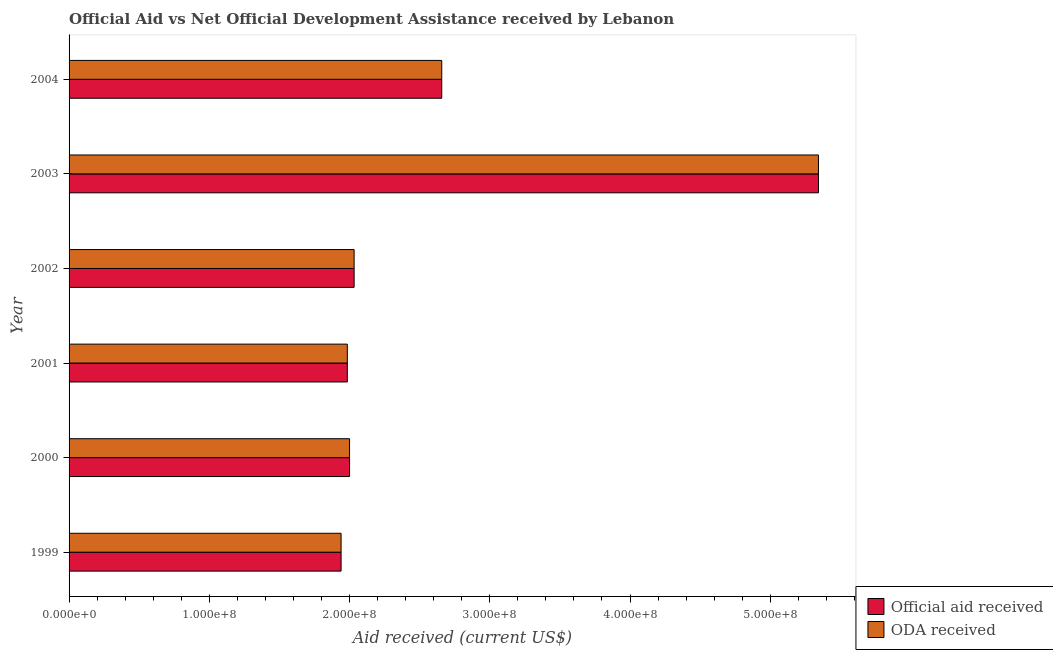How many different coloured bars are there?
Provide a short and direct response. 2. How many groups of bars are there?
Your answer should be compact. 6. Are the number of bars per tick equal to the number of legend labels?
Your response must be concise. Yes. Are the number of bars on each tick of the Y-axis equal?
Provide a short and direct response. Yes. How many bars are there on the 6th tick from the top?
Your response must be concise. 2. What is the label of the 1st group of bars from the top?
Your answer should be very brief. 2004. In how many cases, is the number of bars for a given year not equal to the number of legend labels?
Your answer should be very brief. 0. What is the official aid received in 2003?
Provide a succinct answer. 5.34e+08. Across all years, what is the maximum official aid received?
Provide a short and direct response. 5.34e+08. Across all years, what is the minimum oda received?
Make the answer very short. 1.94e+08. What is the total oda received in the graph?
Your answer should be very brief. 1.60e+09. What is the difference between the oda received in 2000 and that in 2002?
Give a very brief answer. -3.26e+06. What is the difference between the oda received in 2004 and the official aid received in 2003?
Offer a terse response. -2.69e+08. What is the average official aid received per year?
Keep it short and to the point. 2.66e+08. In the year 2004, what is the difference between the oda received and official aid received?
Provide a short and direct response. 0. In how many years, is the official aid received greater than 360000000 US$?
Offer a very short reply. 1. What is the ratio of the oda received in 2003 to that in 2004?
Provide a short and direct response. 2.01. What is the difference between the highest and the second highest oda received?
Keep it short and to the point. 2.69e+08. What is the difference between the highest and the lowest official aid received?
Offer a very short reply. 3.40e+08. What does the 2nd bar from the top in 2004 represents?
Your answer should be compact. Official aid received. What does the 2nd bar from the bottom in 1999 represents?
Your answer should be compact. ODA received. How many bars are there?
Provide a succinct answer. 12. What is the difference between two consecutive major ticks on the X-axis?
Offer a terse response. 1.00e+08. Are the values on the major ticks of X-axis written in scientific E-notation?
Your answer should be very brief. Yes. How many legend labels are there?
Provide a short and direct response. 2. What is the title of the graph?
Ensure brevity in your answer.  Official Aid vs Net Official Development Assistance received by Lebanon . Does "Taxes on exports" appear as one of the legend labels in the graph?
Your response must be concise. No. What is the label or title of the X-axis?
Provide a succinct answer. Aid received (current US$). What is the label or title of the Y-axis?
Give a very brief answer. Year. What is the Aid received (current US$) in Official aid received in 1999?
Give a very brief answer. 1.94e+08. What is the Aid received (current US$) of ODA received in 1999?
Make the answer very short. 1.94e+08. What is the Aid received (current US$) of Official aid received in 2000?
Offer a terse response. 2.00e+08. What is the Aid received (current US$) in ODA received in 2000?
Provide a short and direct response. 2.00e+08. What is the Aid received (current US$) in Official aid received in 2001?
Provide a short and direct response. 1.98e+08. What is the Aid received (current US$) of ODA received in 2001?
Ensure brevity in your answer.  1.98e+08. What is the Aid received (current US$) in Official aid received in 2002?
Ensure brevity in your answer.  2.03e+08. What is the Aid received (current US$) in ODA received in 2002?
Give a very brief answer. 2.03e+08. What is the Aid received (current US$) of Official aid received in 2003?
Ensure brevity in your answer.  5.34e+08. What is the Aid received (current US$) in ODA received in 2003?
Your answer should be compact. 5.34e+08. What is the Aid received (current US$) of Official aid received in 2004?
Give a very brief answer. 2.66e+08. What is the Aid received (current US$) of ODA received in 2004?
Offer a very short reply. 2.66e+08. Across all years, what is the maximum Aid received (current US$) in Official aid received?
Your answer should be very brief. 5.34e+08. Across all years, what is the maximum Aid received (current US$) in ODA received?
Your answer should be compact. 5.34e+08. Across all years, what is the minimum Aid received (current US$) in Official aid received?
Ensure brevity in your answer.  1.94e+08. Across all years, what is the minimum Aid received (current US$) in ODA received?
Provide a short and direct response. 1.94e+08. What is the total Aid received (current US$) in Official aid received in the graph?
Give a very brief answer. 1.60e+09. What is the total Aid received (current US$) in ODA received in the graph?
Offer a very short reply. 1.60e+09. What is the difference between the Aid received (current US$) in Official aid received in 1999 and that in 2000?
Ensure brevity in your answer.  -6.05e+06. What is the difference between the Aid received (current US$) in ODA received in 1999 and that in 2000?
Offer a very short reply. -6.05e+06. What is the difference between the Aid received (current US$) in Official aid received in 1999 and that in 2001?
Offer a very short reply. -4.46e+06. What is the difference between the Aid received (current US$) in ODA received in 1999 and that in 2001?
Your response must be concise. -4.46e+06. What is the difference between the Aid received (current US$) in Official aid received in 1999 and that in 2002?
Ensure brevity in your answer.  -9.31e+06. What is the difference between the Aid received (current US$) in ODA received in 1999 and that in 2002?
Keep it short and to the point. -9.31e+06. What is the difference between the Aid received (current US$) of Official aid received in 1999 and that in 2003?
Provide a succinct answer. -3.40e+08. What is the difference between the Aid received (current US$) in ODA received in 1999 and that in 2003?
Make the answer very short. -3.40e+08. What is the difference between the Aid received (current US$) of Official aid received in 1999 and that in 2004?
Your answer should be very brief. -7.18e+07. What is the difference between the Aid received (current US$) in ODA received in 1999 and that in 2004?
Make the answer very short. -7.18e+07. What is the difference between the Aid received (current US$) in Official aid received in 2000 and that in 2001?
Your answer should be very brief. 1.59e+06. What is the difference between the Aid received (current US$) of ODA received in 2000 and that in 2001?
Your answer should be compact. 1.59e+06. What is the difference between the Aid received (current US$) of Official aid received in 2000 and that in 2002?
Offer a terse response. -3.26e+06. What is the difference between the Aid received (current US$) in ODA received in 2000 and that in 2002?
Ensure brevity in your answer.  -3.26e+06. What is the difference between the Aid received (current US$) of Official aid received in 2000 and that in 2003?
Your answer should be very brief. -3.34e+08. What is the difference between the Aid received (current US$) in ODA received in 2000 and that in 2003?
Offer a terse response. -3.34e+08. What is the difference between the Aid received (current US$) in Official aid received in 2000 and that in 2004?
Your answer should be very brief. -6.57e+07. What is the difference between the Aid received (current US$) in ODA received in 2000 and that in 2004?
Keep it short and to the point. -6.57e+07. What is the difference between the Aid received (current US$) in Official aid received in 2001 and that in 2002?
Keep it short and to the point. -4.85e+06. What is the difference between the Aid received (current US$) of ODA received in 2001 and that in 2002?
Your answer should be very brief. -4.85e+06. What is the difference between the Aid received (current US$) of Official aid received in 2001 and that in 2003?
Provide a succinct answer. -3.36e+08. What is the difference between the Aid received (current US$) in ODA received in 2001 and that in 2003?
Your answer should be compact. -3.36e+08. What is the difference between the Aid received (current US$) of Official aid received in 2001 and that in 2004?
Your response must be concise. -6.73e+07. What is the difference between the Aid received (current US$) of ODA received in 2001 and that in 2004?
Make the answer very short. -6.73e+07. What is the difference between the Aid received (current US$) of Official aid received in 2002 and that in 2003?
Offer a terse response. -3.31e+08. What is the difference between the Aid received (current US$) of ODA received in 2002 and that in 2003?
Make the answer very short. -3.31e+08. What is the difference between the Aid received (current US$) in Official aid received in 2002 and that in 2004?
Your response must be concise. -6.25e+07. What is the difference between the Aid received (current US$) in ODA received in 2002 and that in 2004?
Offer a terse response. -6.25e+07. What is the difference between the Aid received (current US$) in Official aid received in 2003 and that in 2004?
Ensure brevity in your answer.  2.69e+08. What is the difference between the Aid received (current US$) in ODA received in 2003 and that in 2004?
Your answer should be very brief. 2.69e+08. What is the difference between the Aid received (current US$) of Official aid received in 1999 and the Aid received (current US$) of ODA received in 2000?
Offer a terse response. -6.05e+06. What is the difference between the Aid received (current US$) in Official aid received in 1999 and the Aid received (current US$) in ODA received in 2001?
Provide a short and direct response. -4.46e+06. What is the difference between the Aid received (current US$) in Official aid received in 1999 and the Aid received (current US$) in ODA received in 2002?
Make the answer very short. -9.31e+06. What is the difference between the Aid received (current US$) in Official aid received in 1999 and the Aid received (current US$) in ODA received in 2003?
Offer a terse response. -3.40e+08. What is the difference between the Aid received (current US$) of Official aid received in 1999 and the Aid received (current US$) of ODA received in 2004?
Provide a short and direct response. -7.18e+07. What is the difference between the Aid received (current US$) of Official aid received in 2000 and the Aid received (current US$) of ODA received in 2001?
Keep it short and to the point. 1.59e+06. What is the difference between the Aid received (current US$) of Official aid received in 2000 and the Aid received (current US$) of ODA received in 2002?
Give a very brief answer. -3.26e+06. What is the difference between the Aid received (current US$) of Official aid received in 2000 and the Aid received (current US$) of ODA received in 2003?
Make the answer very short. -3.34e+08. What is the difference between the Aid received (current US$) of Official aid received in 2000 and the Aid received (current US$) of ODA received in 2004?
Provide a succinct answer. -6.57e+07. What is the difference between the Aid received (current US$) of Official aid received in 2001 and the Aid received (current US$) of ODA received in 2002?
Your answer should be very brief. -4.85e+06. What is the difference between the Aid received (current US$) of Official aid received in 2001 and the Aid received (current US$) of ODA received in 2003?
Offer a terse response. -3.36e+08. What is the difference between the Aid received (current US$) in Official aid received in 2001 and the Aid received (current US$) in ODA received in 2004?
Offer a terse response. -6.73e+07. What is the difference between the Aid received (current US$) in Official aid received in 2002 and the Aid received (current US$) in ODA received in 2003?
Your answer should be very brief. -3.31e+08. What is the difference between the Aid received (current US$) in Official aid received in 2002 and the Aid received (current US$) in ODA received in 2004?
Keep it short and to the point. -6.25e+07. What is the difference between the Aid received (current US$) of Official aid received in 2003 and the Aid received (current US$) of ODA received in 2004?
Ensure brevity in your answer.  2.69e+08. What is the average Aid received (current US$) of Official aid received per year?
Keep it short and to the point. 2.66e+08. What is the average Aid received (current US$) in ODA received per year?
Your answer should be compact. 2.66e+08. In the year 2000, what is the difference between the Aid received (current US$) of Official aid received and Aid received (current US$) of ODA received?
Make the answer very short. 0. In the year 2002, what is the difference between the Aid received (current US$) of Official aid received and Aid received (current US$) of ODA received?
Ensure brevity in your answer.  0. In the year 2004, what is the difference between the Aid received (current US$) in Official aid received and Aid received (current US$) in ODA received?
Ensure brevity in your answer.  0. What is the ratio of the Aid received (current US$) in Official aid received in 1999 to that in 2000?
Provide a short and direct response. 0.97. What is the ratio of the Aid received (current US$) of ODA received in 1999 to that in 2000?
Offer a terse response. 0.97. What is the ratio of the Aid received (current US$) of Official aid received in 1999 to that in 2001?
Your response must be concise. 0.98. What is the ratio of the Aid received (current US$) of ODA received in 1999 to that in 2001?
Your answer should be compact. 0.98. What is the ratio of the Aid received (current US$) in Official aid received in 1999 to that in 2002?
Provide a short and direct response. 0.95. What is the ratio of the Aid received (current US$) in ODA received in 1999 to that in 2002?
Ensure brevity in your answer.  0.95. What is the ratio of the Aid received (current US$) in Official aid received in 1999 to that in 2003?
Ensure brevity in your answer.  0.36. What is the ratio of the Aid received (current US$) of ODA received in 1999 to that in 2003?
Provide a succinct answer. 0.36. What is the ratio of the Aid received (current US$) of Official aid received in 1999 to that in 2004?
Make the answer very short. 0.73. What is the ratio of the Aid received (current US$) of ODA received in 1999 to that in 2004?
Make the answer very short. 0.73. What is the ratio of the Aid received (current US$) in Official aid received in 2000 to that in 2001?
Give a very brief answer. 1.01. What is the ratio of the Aid received (current US$) in Official aid received in 2000 to that in 2002?
Your answer should be very brief. 0.98. What is the ratio of the Aid received (current US$) in Official aid received in 2000 to that in 2003?
Provide a short and direct response. 0.37. What is the ratio of the Aid received (current US$) in ODA received in 2000 to that in 2003?
Give a very brief answer. 0.37. What is the ratio of the Aid received (current US$) of Official aid received in 2000 to that in 2004?
Your answer should be very brief. 0.75. What is the ratio of the Aid received (current US$) of ODA received in 2000 to that in 2004?
Your answer should be compact. 0.75. What is the ratio of the Aid received (current US$) of Official aid received in 2001 to that in 2002?
Offer a very short reply. 0.98. What is the ratio of the Aid received (current US$) in ODA received in 2001 to that in 2002?
Ensure brevity in your answer.  0.98. What is the ratio of the Aid received (current US$) of Official aid received in 2001 to that in 2003?
Offer a very short reply. 0.37. What is the ratio of the Aid received (current US$) of ODA received in 2001 to that in 2003?
Provide a short and direct response. 0.37. What is the ratio of the Aid received (current US$) in Official aid received in 2001 to that in 2004?
Make the answer very short. 0.75. What is the ratio of the Aid received (current US$) of ODA received in 2001 to that in 2004?
Give a very brief answer. 0.75. What is the ratio of the Aid received (current US$) of Official aid received in 2002 to that in 2003?
Give a very brief answer. 0.38. What is the ratio of the Aid received (current US$) of ODA received in 2002 to that in 2003?
Offer a terse response. 0.38. What is the ratio of the Aid received (current US$) of Official aid received in 2002 to that in 2004?
Give a very brief answer. 0.76. What is the ratio of the Aid received (current US$) in ODA received in 2002 to that in 2004?
Offer a terse response. 0.76. What is the ratio of the Aid received (current US$) in Official aid received in 2003 to that in 2004?
Your response must be concise. 2.01. What is the ratio of the Aid received (current US$) in ODA received in 2003 to that in 2004?
Offer a very short reply. 2.01. What is the difference between the highest and the second highest Aid received (current US$) in Official aid received?
Your answer should be compact. 2.69e+08. What is the difference between the highest and the second highest Aid received (current US$) of ODA received?
Make the answer very short. 2.69e+08. What is the difference between the highest and the lowest Aid received (current US$) in Official aid received?
Make the answer very short. 3.40e+08. What is the difference between the highest and the lowest Aid received (current US$) of ODA received?
Offer a terse response. 3.40e+08. 